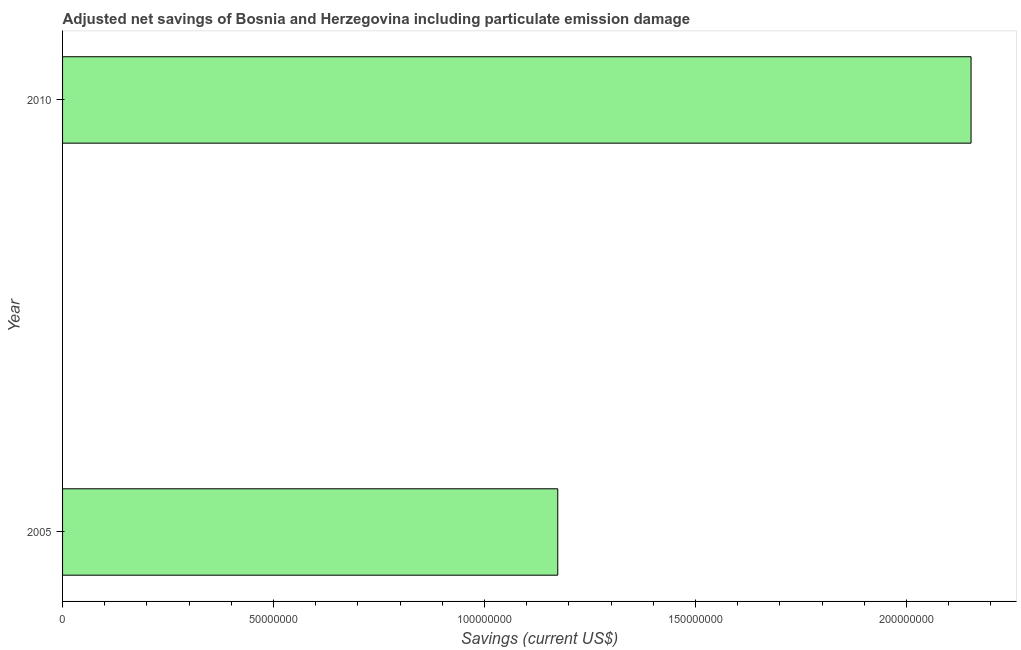Does the graph contain any zero values?
Give a very brief answer. No. Does the graph contain grids?
Provide a short and direct response. No. What is the title of the graph?
Give a very brief answer. Adjusted net savings of Bosnia and Herzegovina including particulate emission damage. What is the label or title of the X-axis?
Provide a succinct answer. Savings (current US$). What is the label or title of the Y-axis?
Your response must be concise. Year. What is the adjusted net savings in 2010?
Your response must be concise. 2.15e+08. Across all years, what is the maximum adjusted net savings?
Offer a very short reply. 2.15e+08. Across all years, what is the minimum adjusted net savings?
Provide a succinct answer. 1.17e+08. In which year was the adjusted net savings maximum?
Provide a succinct answer. 2010. What is the sum of the adjusted net savings?
Your answer should be compact. 3.33e+08. What is the difference between the adjusted net savings in 2005 and 2010?
Your response must be concise. -9.79e+07. What is the average adjusted net savings per year?
Ensure brevity in your answer.  1.66e+08. What is the median adjusted net savings?
Make the answer very short. 1.66e+08. In how many years, is the adjusted net savings greater than 190000000 US$?
Offer a very short reply. 1. What is the ratio of the adjusted net savings in 2005 to that in 2010?
Your answer should be very brief. 0.55. Is the adjusted net savings in 2005 less than that in 2010?
Make the answer very short. Yes. In how many years, is the adjusted net savings greater than the average adjusted net savings taken over all years?
Offer a very short reply. 1. How many years are there in the graph?
Your answer should be compact. 2. What is the difference between two consecutive major ticks on the X-axis?
Give a very brief answer. 5.00e+07. What is the Savings (current US$) in 2005?
Give a very brief answer. 1.17e+08. What is the Savings (current US$) of 2010?
Your answer should be compact. 2.15e+08. What is the difference between the Savings (current US$) in 2005 and 2010?
Provide a succinct answer. -9.79e+07. What is the ratio of the Savings (current US$) in 2005 to that in 2010?
Your answer should be very brief. 0.55. 